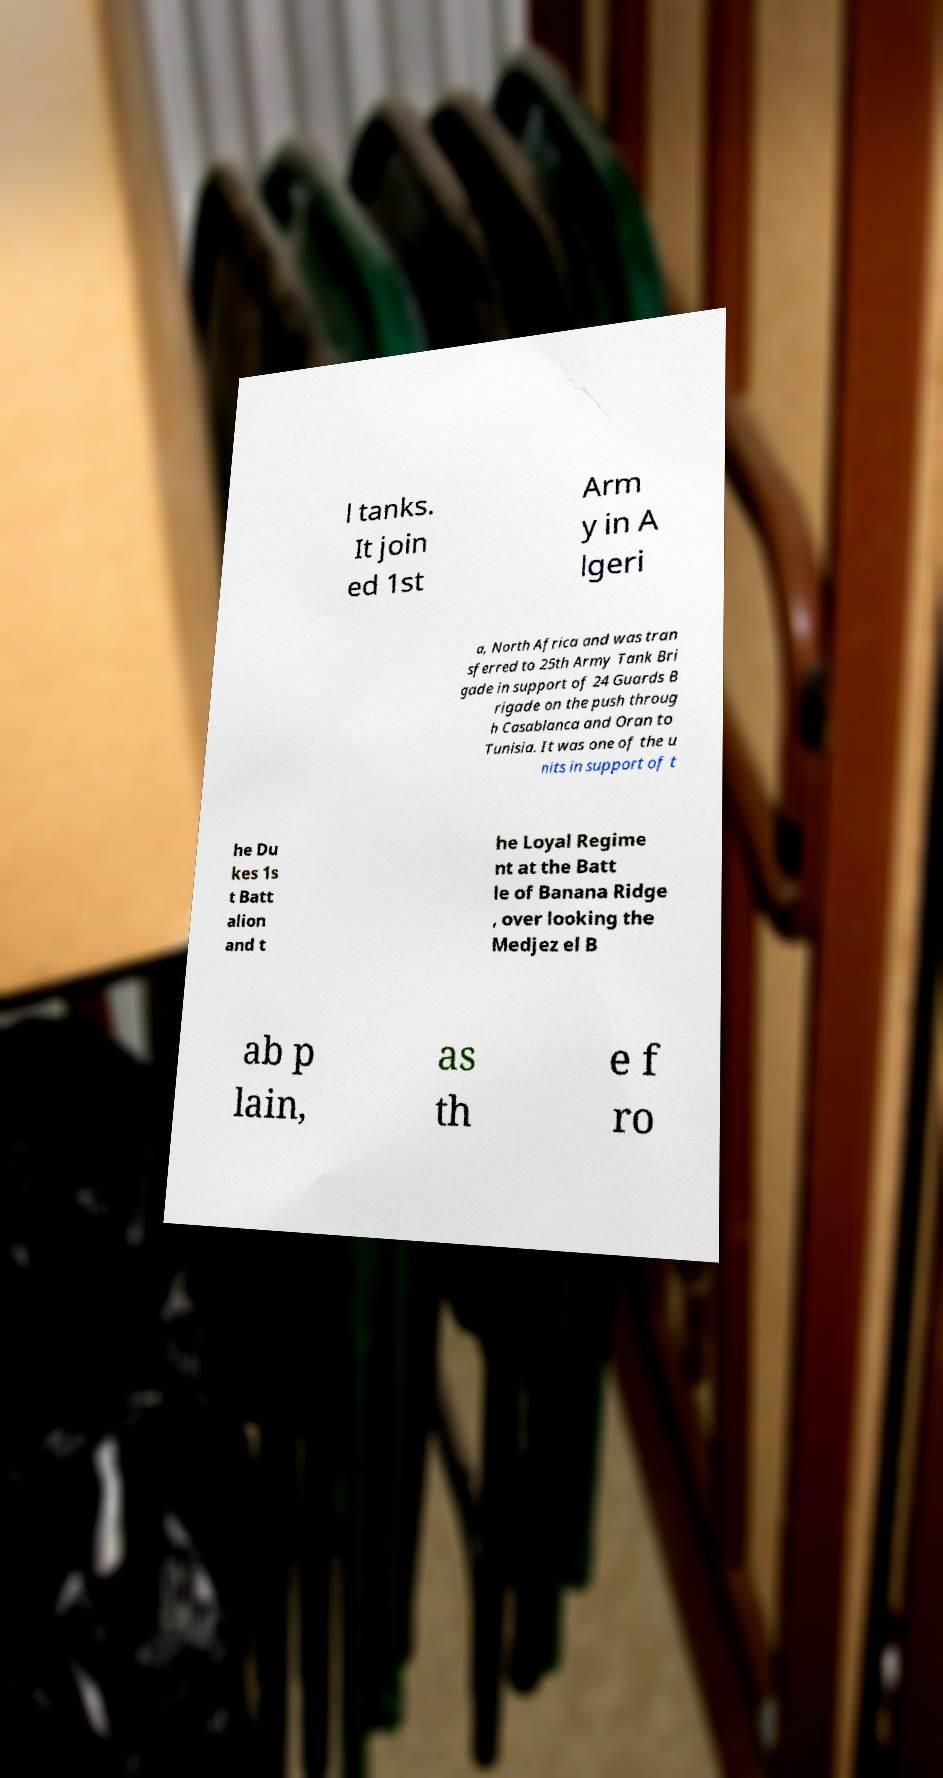Could you assist in decoding the text presented in this image and type it out clearly? l tanks. It join ed 1st Arm y in A lgeri a, North Africa and was tran sferred to 25th Army Tank Bri gade in support of 24 Guards B rigade on the push throug h Casablanca and Oran to Tunisia. It was one of the u nits in support of t he Du kes 1s t Batt alion and t he Loyal Regime nt at the Batt le of Banana Ridge , over looking the Medjez el B ab p lain, as th e f ro 